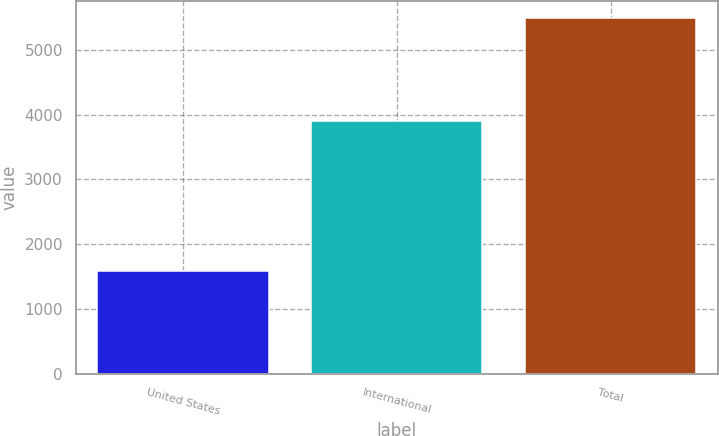Convert chart to OTSL. <chart><loc_0><loc_0><loc_500><loc_500><bar_chart><fcel>United States<fcel>International<fcel>Total<nl><fcel>1584.7<fcel>3899<fcel>5483.7<nl></chart> 